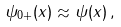<formula> <loc_0><loc_0><loc_500><loc_500>\psi _ { 0 + } ( x ) \approx \psi ( x ) \, ,</formula> 